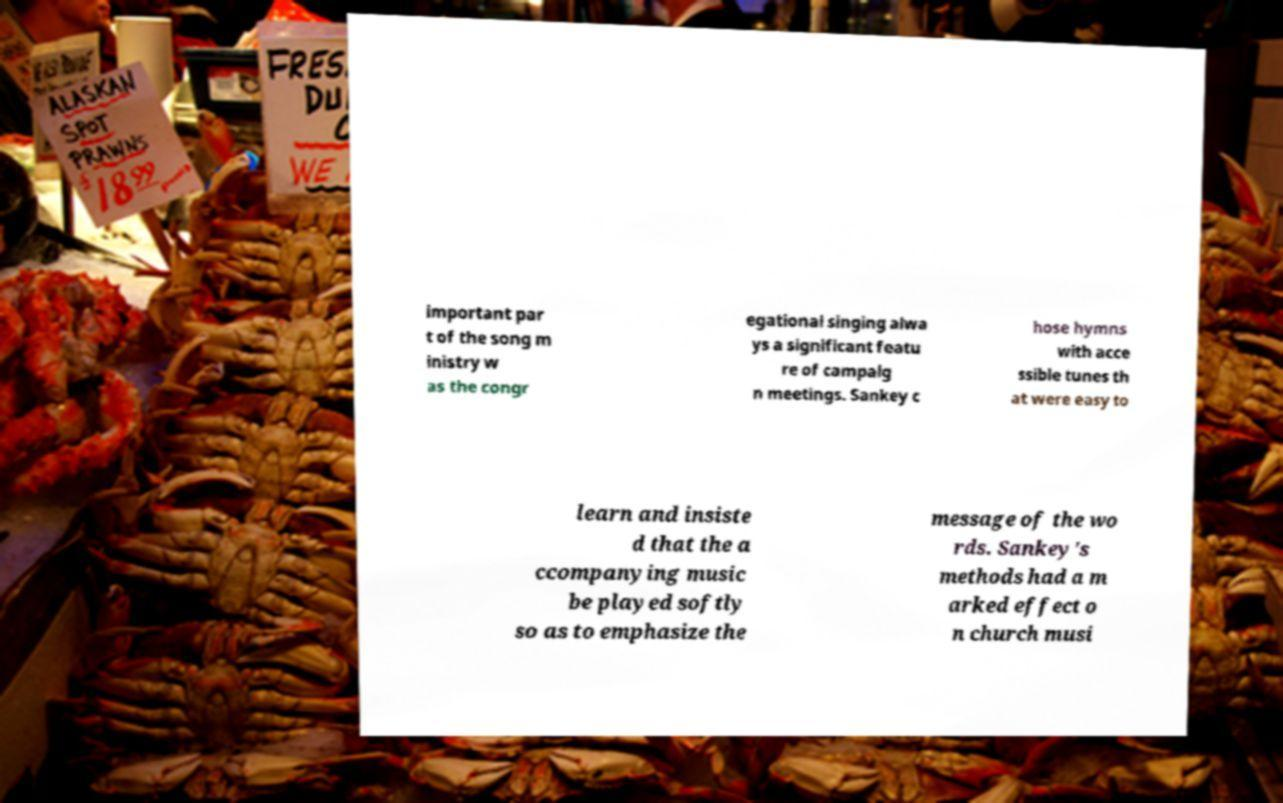Please read and relay the text visible in this image. What does it say? important par t of the song m inistry w as the congr egational singing alwa ys a significant featu re of campaig n meetings. Sankey c hose hymns with acce ssible tunes th at were easy to learn and insiste d that the a ccompanying music be played softly so as to emphasize the message of the wo rds. Sankey's methods had a m arked effect o n church musi 